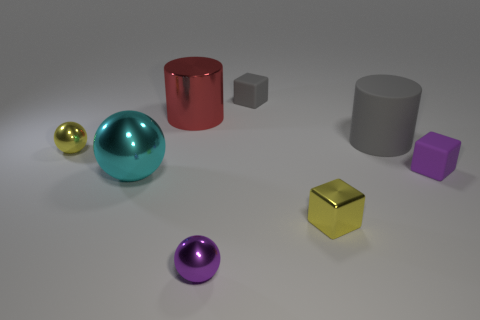Does the metal cylinder have the same color as the large matte cylinder?
Give a very brief answer. No. How many other objects are the same size as the yellow cube?
Make the answer very short. 4. What number of objects are either large shiny things or metal objects that are left of the red object?
Make the answer very short. 3. Is the number of big gray matte cylinders on the left side of the cyan metallic sphere the same as the number of red things?
Your answer should be compact. No. The small thing that is made of the same material as the small gray block is what shape?
Provide a succinct answer. Cube. Are there any large spheres of the same color as the big rubber cylinder?
Make the answer very short. No. How many metallic objects are either big gray cubes or small purple cubes?
Your answer should be compact. 0. How many purple shiny objects are on the right side of the small yellow metallic object that is in front of the tiny purple rubber block?
Provide a succinct answer. 0. What number of big cylinders have the same material as the gray block?
Make the answer very short. 1. How many big objects are yellow matte things or yellow metallic balls?
Your answer should be very brief. 0. 